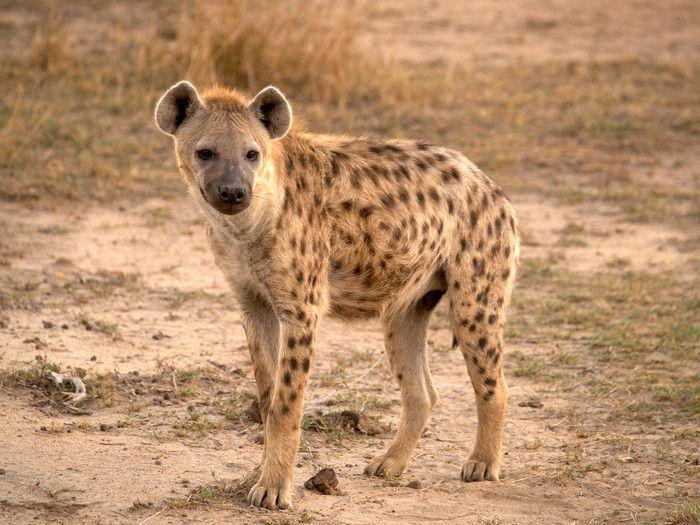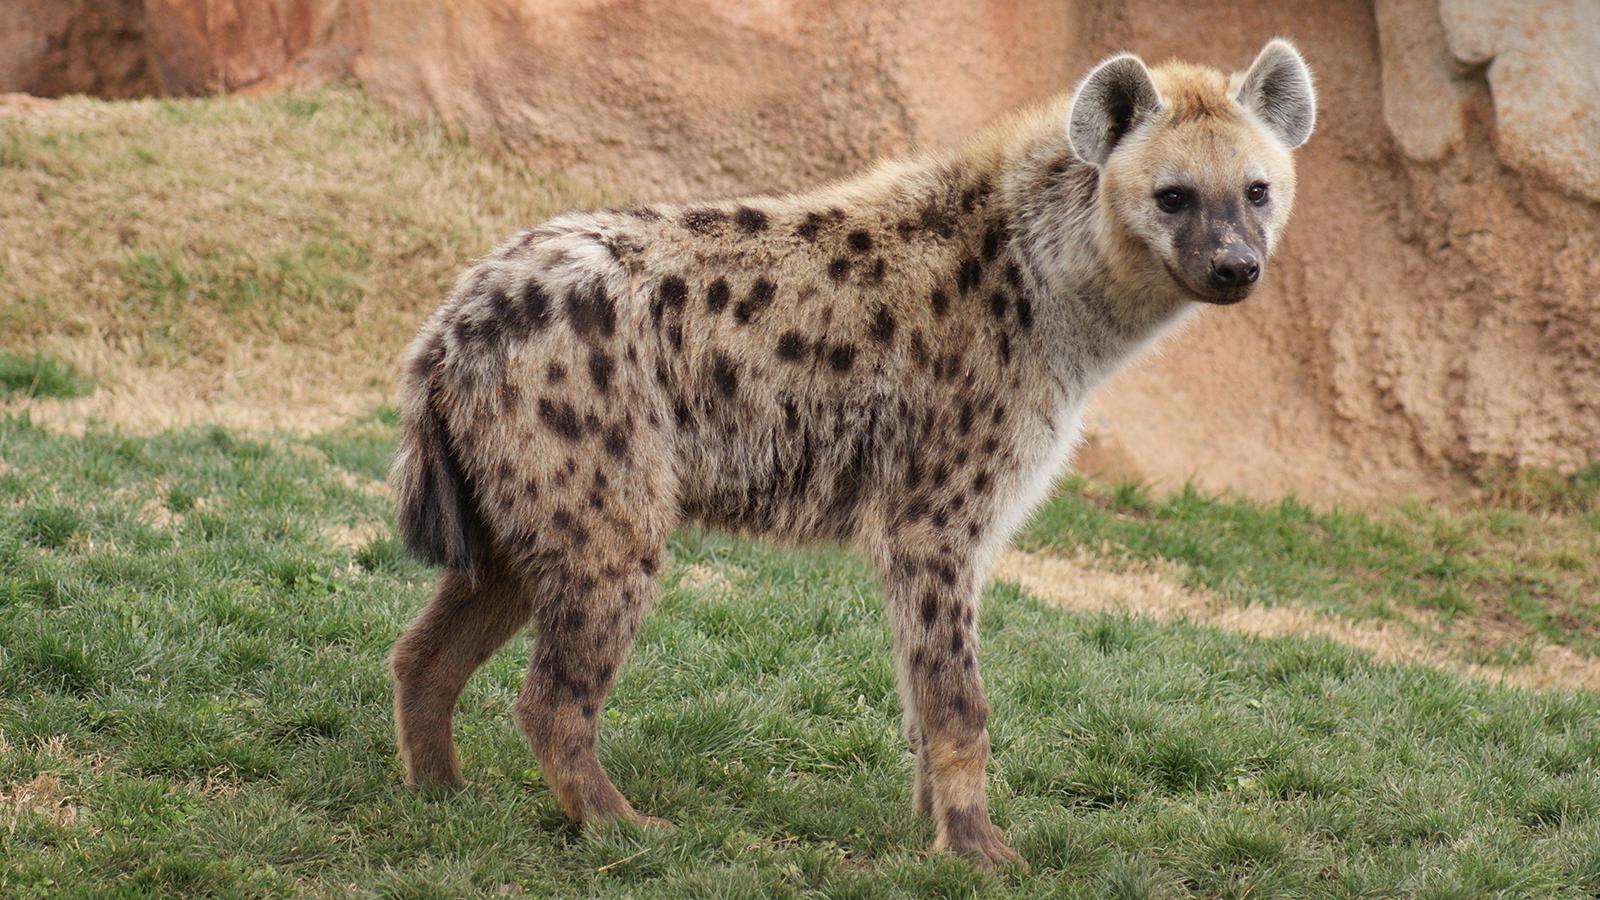The first image is the image on the left, the second image is the image on the right. Examine the images to the left and right. Is the description "The hyena on the right image is facing left." accurate? Answer yes or no. No. 